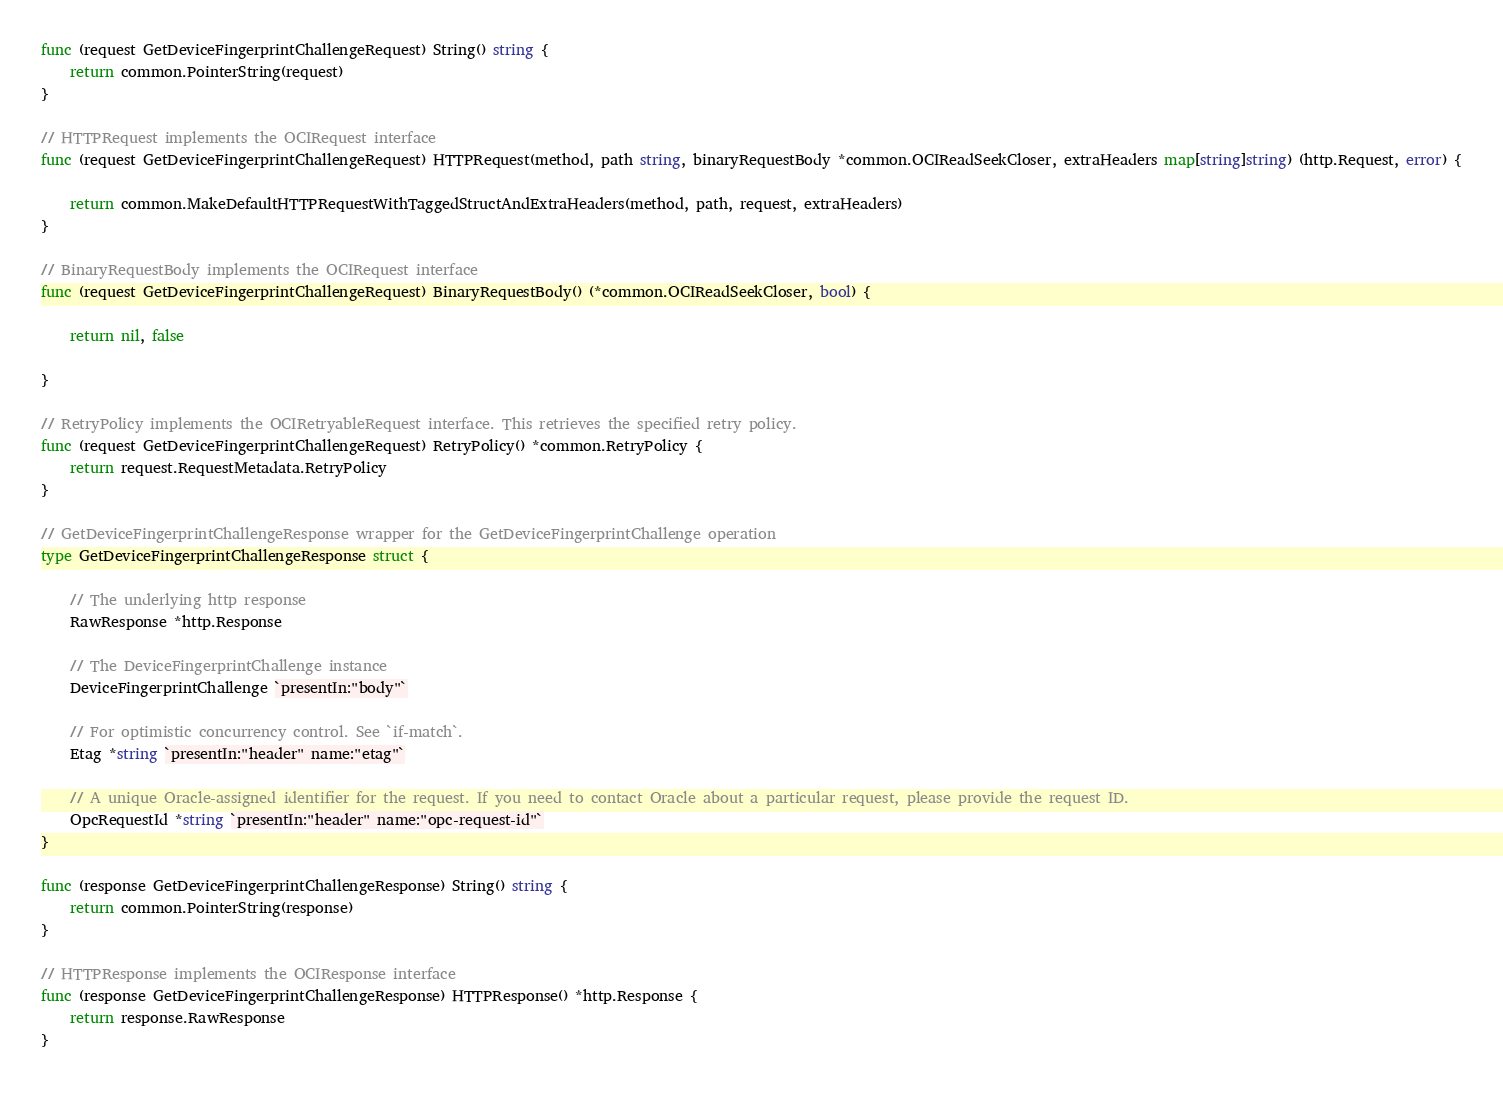Convert code to text. <code><loc_0><loc_0><loc_500><loc_500><_Go_>func (request GetDeviceFingerprintChallengeRequest) String() string {
	return common.PointerString(request)
}

// HTTPRequest implements the OCIRequest interface
func (request GetDeviceFingerprintChallengeRequest) HTTPRequest(method, path string, binaryRequestBody *common.OCIReadSeekCloser, extraHeaders map[string]string) (http.Request, error) {

	return common.MakeDefaultHTTPRequestWithTaggedStructAndExtraHeaders(method, path, request, extraHeaders)
}

// BinaryRequestBody implements the OCIRequest interface
func (request GetDeviceFingerprintChallengeRequest) BinaryRequestBody() (*common.OCIReadSeekCloser, bool) {

	return nil, false

}

// RetryPolicy implements the OCIRetryableRequest interface. This retrieves the specified retry policy.
func (request GetDeviceFingerprintChallengeRequest) RetryPolicy() *common.RetryPolicy {
	return request.RequestMetadata.RetryPolicy
}

// GetDeviceFingerprintChallengeResponse wrapper for the GetDeviceFingerprintChallenge operation
type GetDeviceFingerprintChallengeResponse struct {

	// The underlying http response
	RawResponse *http.Response

	// The DeviceFingerprintChallenge instance
	DeviceFingerprintChallenge `presentIn:"body"`

	// For optimistic concurrency control. See `if-match`.
	Etag *string `presentIn:"header" name:"etag"`

	// A unique Oracle-assigned identifier for the request. If you need to contact Oracle about a particular request, please provide the request ID.
	OpcRequestId *string `presentIn:"header" name:"opc-request-id"`
}

func (response GetDeviceFingerprintChallengeResponse) String() string {
	return common.PointerString(response)
}

// HTTPResponse implements the OCIResponse interface
func (response GetDeviceFingerprintChallengeResponse) HTTPResponse() *http.Response {
	return response.RawResponse
}
</code> 